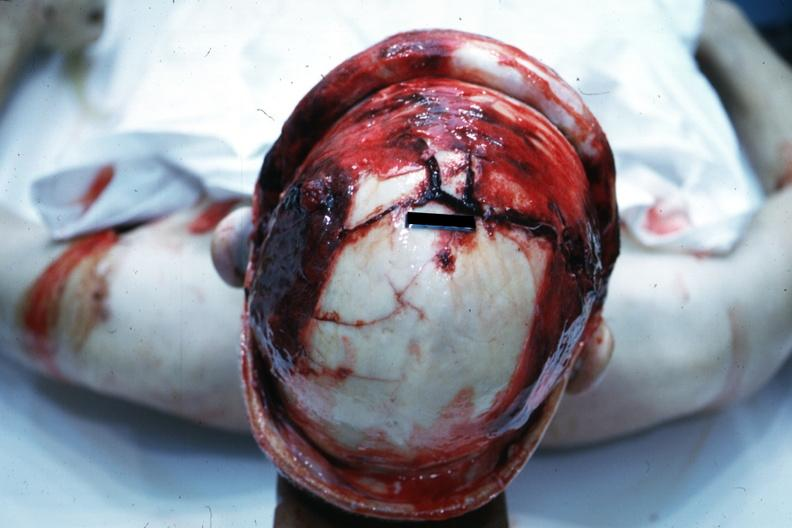what does this image show?
Answer the question using a single word or phrase. View of head with scalp retracted to show massive fractures 